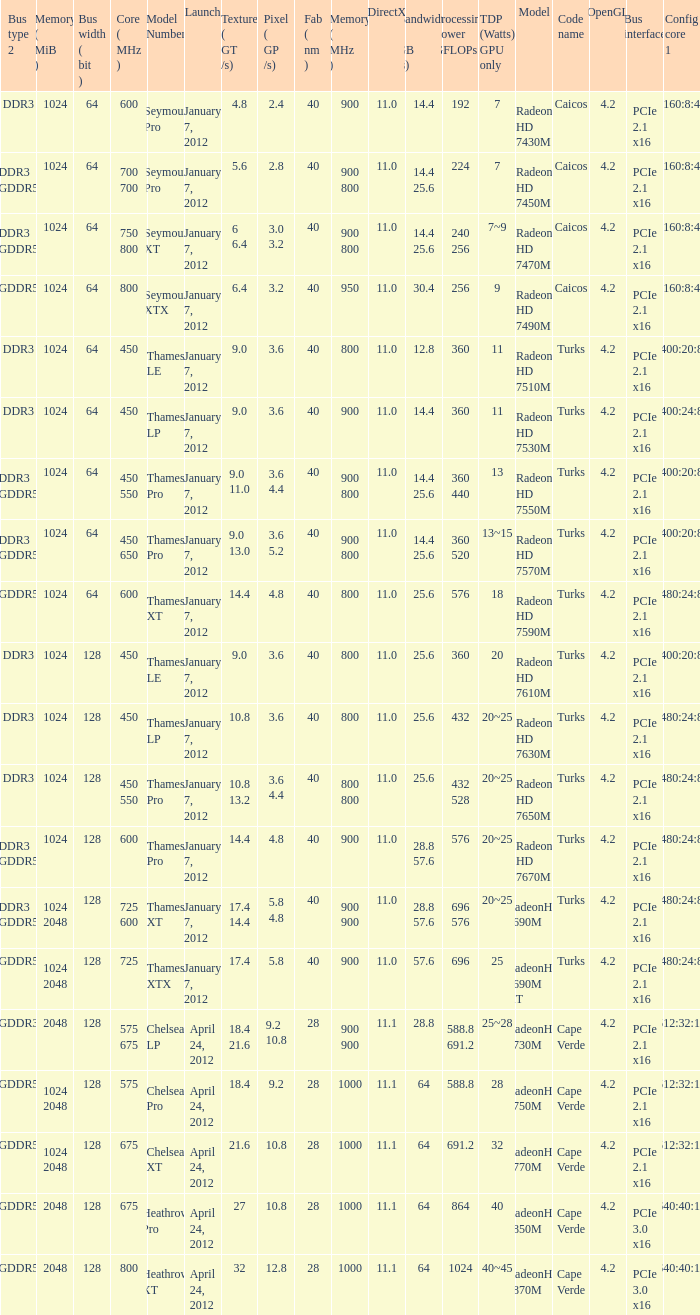How many texture (gt/s) the card has if the tdp (watts) GPU only is 18? 1.0. 